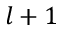Convert formula to latex. <formula><loc_0><loc_0><loc_500><loc_500>l + 1</formula> 